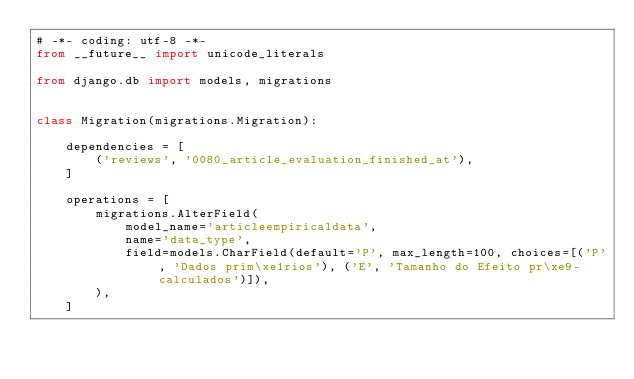<code> <loc_0><loc_0><loc_500><loc_500><_Python_># -*- coding: utf-8 -*-
from __future__ import unicode_literals

from django.db import models, migrations


class Migration(migrations.Migration):

    dependencies = [
        ('reviews', '0080_article_evaluation_finished_at'),
    ]

    operations = [
        migrations.AlterField(
            model_name='articleempiricaldata',
            name='data_type',
            field=models.CharField(default='P', max_length=100, choices=[('P', 'Dados prim\xe1rios'), ('E', 'Tamanho do Efeito pr\xe9-calculados')]),
        ),
    ]
</code> 